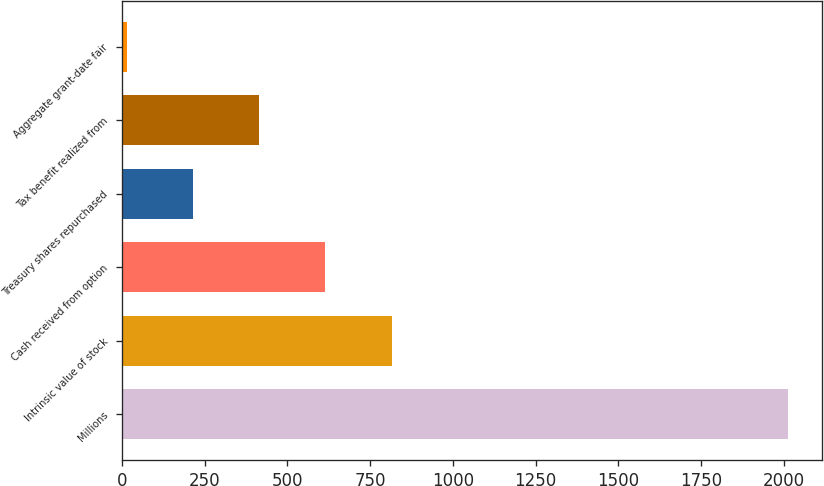Convert chart to OTSL. <chart><loc_0><loc_0><loc_500><loc_500><bar_chart><fcel>Millions<fcel>Intrinsic value of stock<fcel>Cash received from option<fcel>Treasury shares repurchased<fcel>Tax benefit realized from<fcel>Aggregate grant-date fair<nl><fcel>2013<fcel>814.8<fcel>615.1<fcel>215.7<fcel>415.4<fcel>16<nl></chart> 